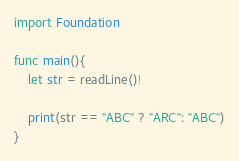Convert code to text. <code><loc_0><loc_0><loc_500><loc_500><_Swift_>import Foundation

func main(){
    let str = readLine()!
    
    print(str == "ABC" ? "ARC": "ABC")
}
</code> 